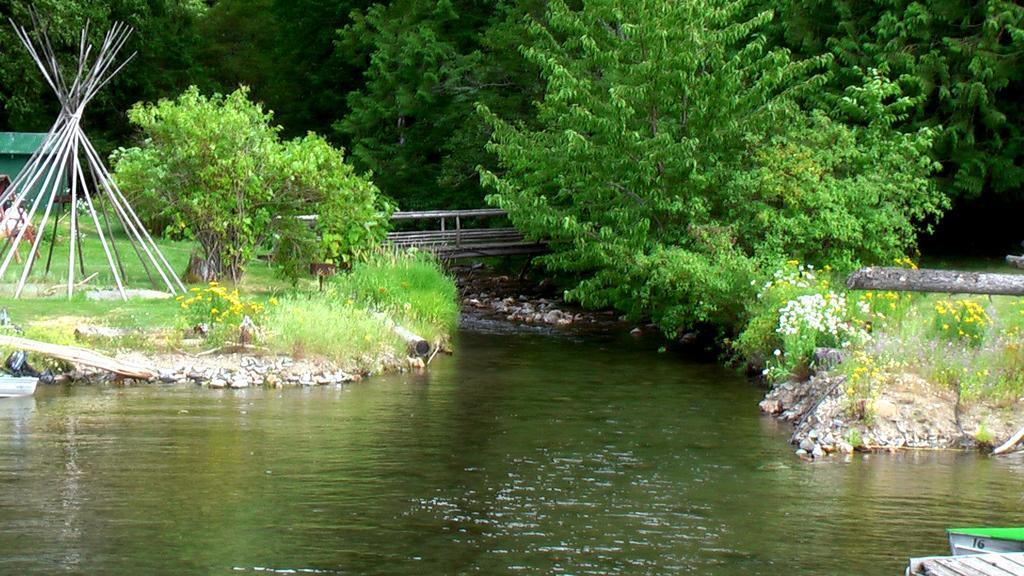Please provide a concise description of this image. In this picture we can see few boats on the water, in the background we can see flowers, trees and a house. 